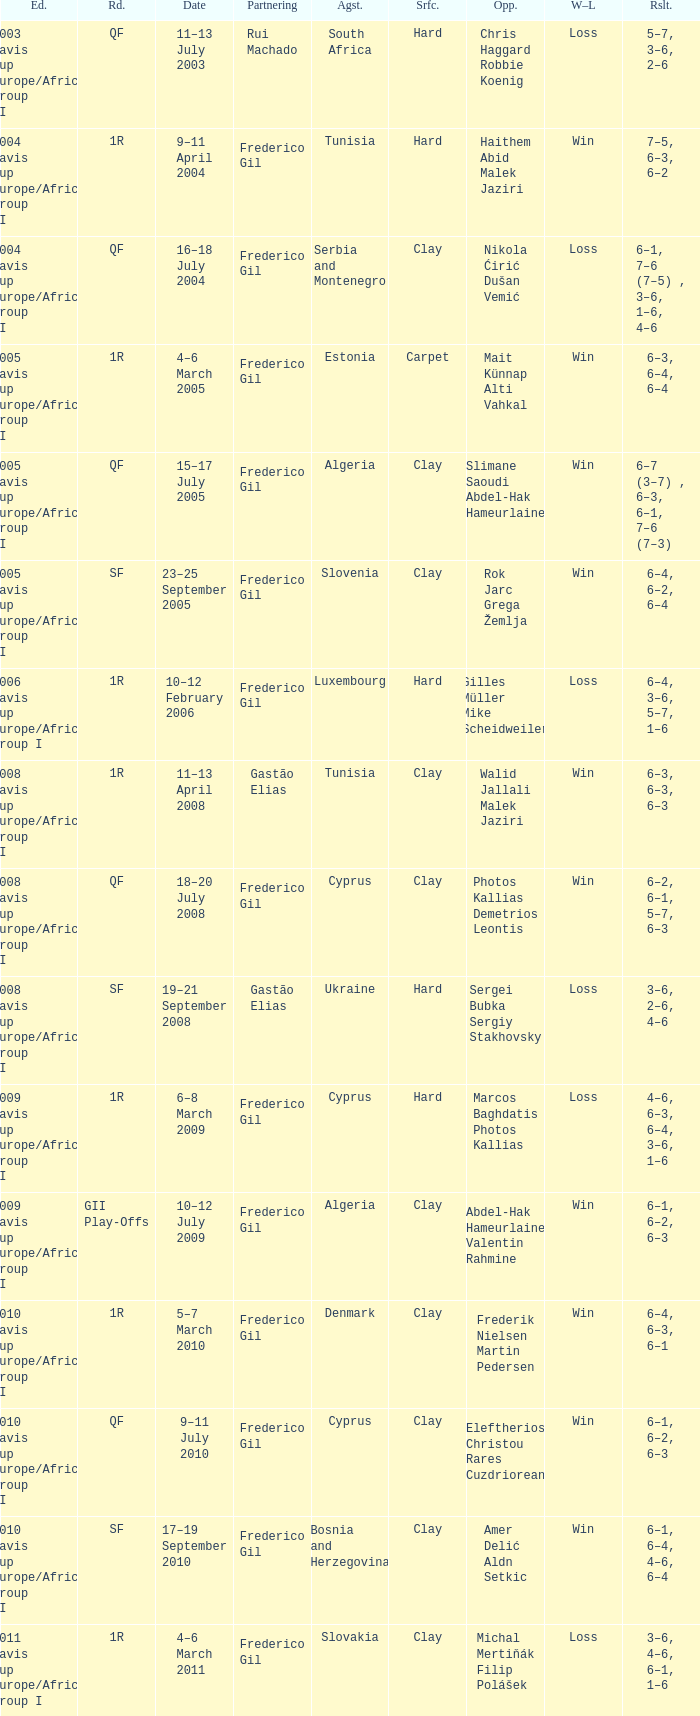How many rounds were there in the 2006 davis cup europe/africa group I? 1.0. 